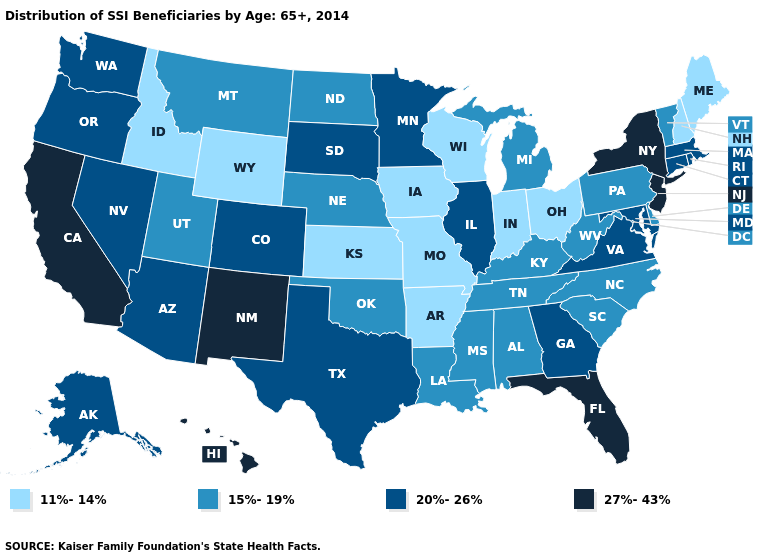Which states have the highest value in the USA?
Short answer required. California, Florida, Hawaii, New Jersey, New Mexico, New York. Does New Hampshire have the same value as Idaho?
Be succinct. Yes. Does Minnesota have the same value as South Carolina?
Give a very brief answer. No. Does Pennsylvania have a lower value than California?
Quick response, please. Yes. Among the states that border South Dakota , which have the lowest value?
Give a very brief answer. Iowa, Wyoming. What is the highest value in the USA?
Keep it brief. 27%-43%. Name the states that have a value in the range 15%-19%?
Short answer required. Alabama, Delaware, Kentucky, Louisiana, Michigan, Mississippi, Montana, Nebraska, North Carolina, North Dakota, Oklahoma, Pennsylvania, South Carolina, Tennessee, Utah, Vermont, West Virginia. Among the states that border Wisconsin , does Minnesota have the highest value?
Quick response, please. Yes. What is the value of New Hampshire?
Quick response, please. 11%-14%. Does New Hampshire have a lower value than Wyoming?
Write a very short answer. No. What is the highest value in the USA?
Concise answer only. 27%-43%. Among the states that border Washington , which have the lowest value?
Be succinct. Idaho. What is the value of Rhode Island?
Short answer required. 20%-26%. What is the highest value in states that border Tennessee?
Quick response, please. 20%-26%. Name the states that have a value in the range 15%-19%?
Give a very brief answer. Alabama, Delaware, Kentucky, Louisiana, Michigan, Mississippi, Montana, Nebraska, North Carolina, North Dakota, Oklahoma, Pennsylvania, South Carolina, Tennessee, Utah, Vermont, West Virginia. 